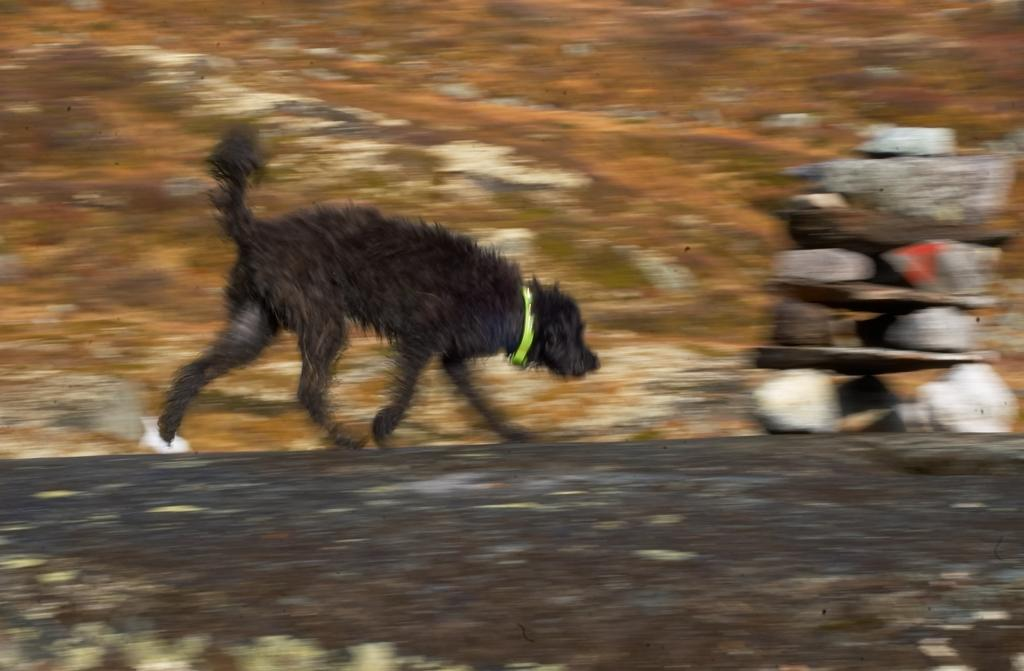What type of animal can be seen in the image? There is a dog in the image. What is the dog doing in the image? The dog is running. What can be seen in the foreground of the image? There are rocks placed on top of each other in the image. What is visible in the background of the image? There are other objects visible in the background of the image. How much sugar is in the jar that is visible in the image? There is no jar present in the image, so it is not possible to determine the amount of sugar in it. 